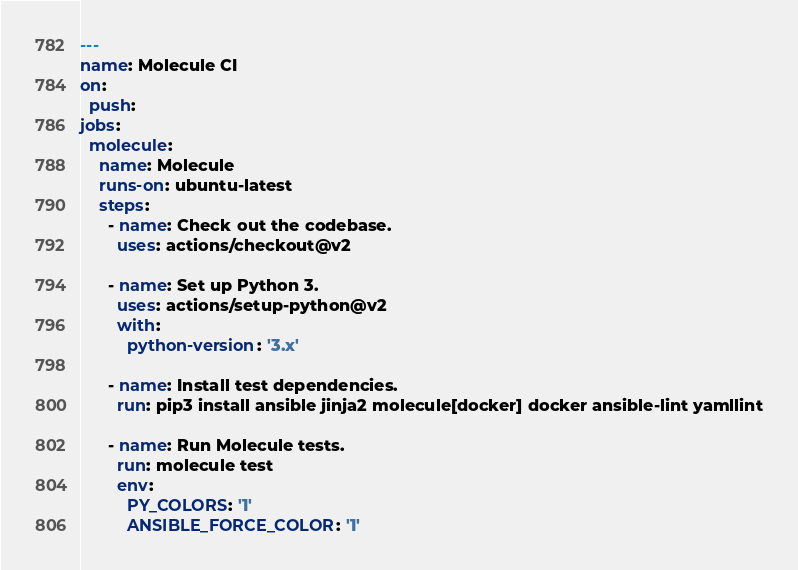Convert code to text. <code><loc_0><loc_0><loc_500><loc_500><_YAML_>---
name: Molecule CI
on:
  push:
jobs:
  molecule:
    name: Molecule
    runs-on: ubuntu-latest
    steps:
      - name: Check out the codebase.
        uses: actions/checkout@v2

      - name: Set up Python 3.
        uses: actions/setup-python@v2
        with:
          python-version: '3.x'

      - name: Install test dependencies.
        run: pip3 install ansible jinja2 molecule[docker] docker ansible-lint yamllint

      - name: Run Molecule tests.
        run: molecule test
        env:
          PY_COLORS: '1'
          ANSIBLE_FORCE_COLOR: '1'
</code> 